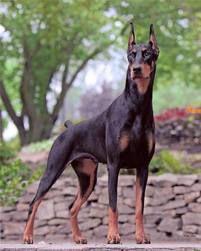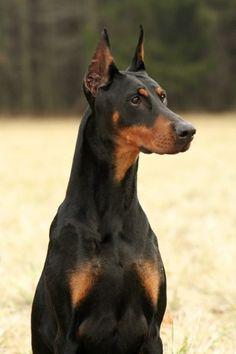The first image is the image on the left, the second image is the image on the right. Evaluate the accuracy of this statement regarding the images: "The left image shows a doberman with erect ears and docked tail standing with his chest facing forward in front of at least one tall tree.". Is it true? Answer yes or no. Yes. The first image is the image on the left, the second image is the image on the right. Analyze the images presented: Is the assertion "in at least one image there is a thin black and brown dog facing forward with their head tilted slightly left." valid? Answer yes or no. No. 